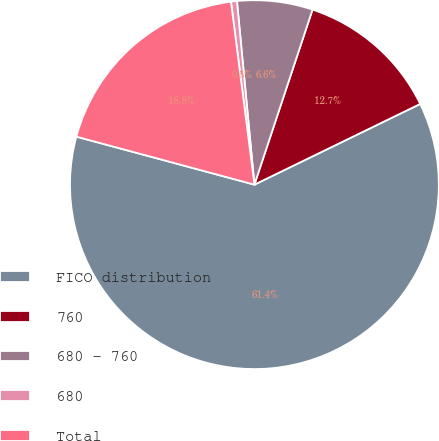<chart> <loc_0><loc_0><loc_500><loc_500><pie_chart><fcel>FICO distribution<fcel>760<fcel>680 - 760<fcel>680<fcel>Total<nl><fcel>61.4%<fcel>12.69%<fcel>6.61%<fcel>0.52%<fcel>18.78%<nl></chart> 